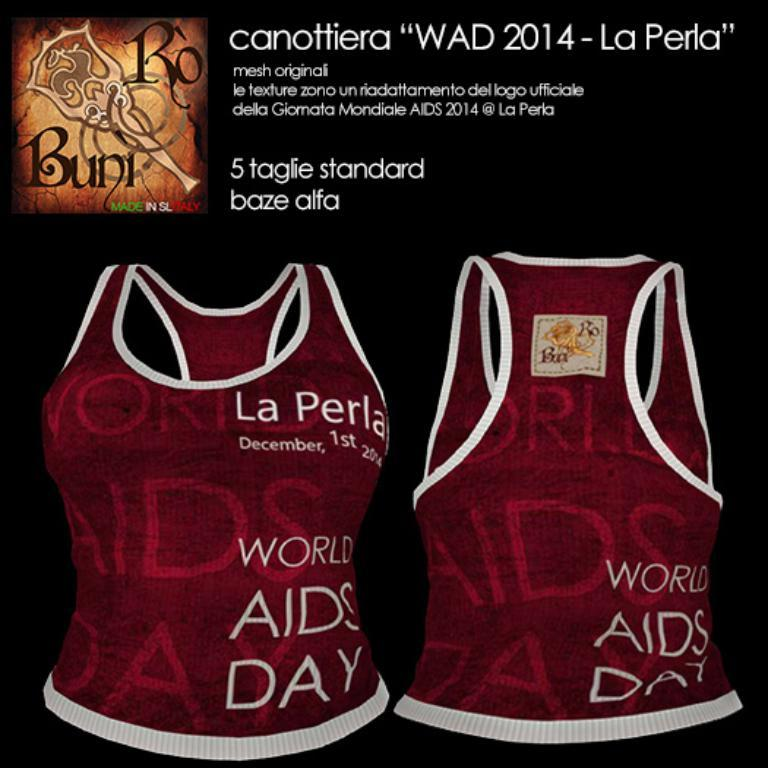<image>
Share a concise interpretation of the image provided. A black print advertisement with shirts reading La Perla on it. 